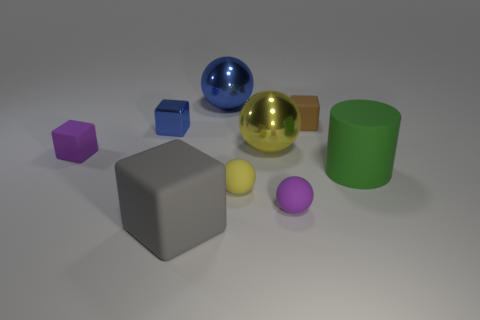Subtract all tiny brown blocks. How many blocks are left? 3 Subtract all yellow spheres. How many spheres are left? 2 Subtract all cyan blocks. How many yellow balls are left? 2 Subtract 0 red cylinders. How many objects are left? 9 Subtract all spheres. How many objects are left? 5 Subtract all gray cubes. Subtract all blue balls. How many cubes are left? 3 Subtract all tiny blue metallic blocks. Subtract all blue metallic things. How many objects are left? 6 Add 9 tiny metal things. How many tiny metal things are left? 10 Add 8 purple cubes. How many purple cubes exist? 9 